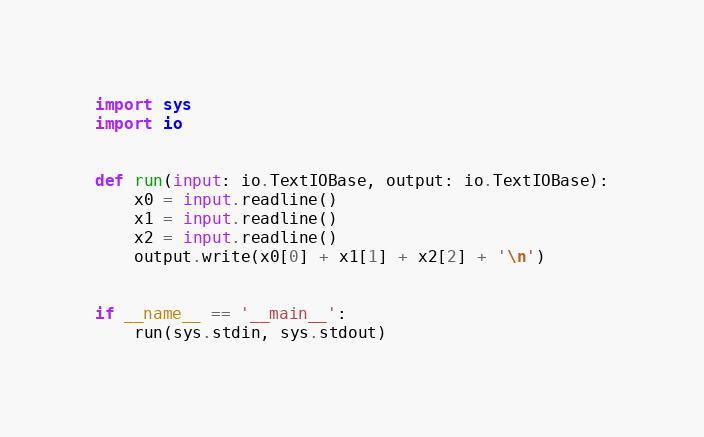Convert code to text. <code><loc_0><loc_0><loc_500><loc_500><_Python_>import sys
import io


def run(input: io.TextIOBase, output: io.TextIOBase):
    x0 = input.readline()
    x1 = input.readline()
    x2 = input.readline()
    output.write(x0[0] + x1[1] + x2[2] + '\n')


if __name__ == '__main__':
    run(sys.stdin, sys.stdout)</code> 